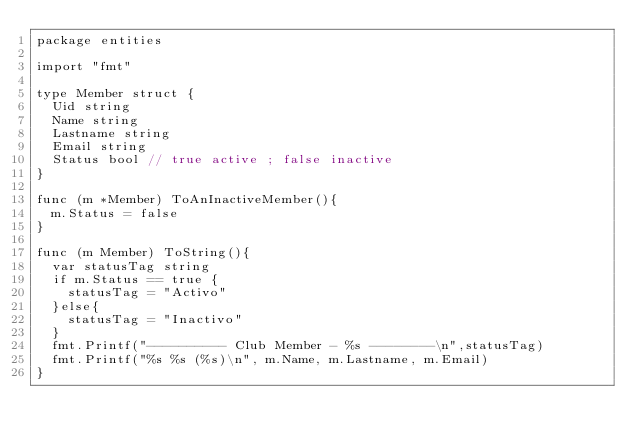<code> <loc_0><loc_0><loc_500><loc_500><_Go_>package entities

import "fmt"

type Member struct {
	Uid string
	Name string
	Lastname string
	Email string
	Status bool // true active ; false inactive
}

func (m *Member) ToAnInactiveMember(){
	m.Status = false
}

func (m Member) ToString(){
	var statusTag string
	if m.Status == true {
		statusTag = "Activo"
	}else{
		statusTag = "Inactivo"
	}
	fmt.Printf("---------- Club Member - %s --------\n",statusTag)
	fmt.Printf("%s %s (%s)\n", m.Name, m.Lastname, m.Email)
}</code> 